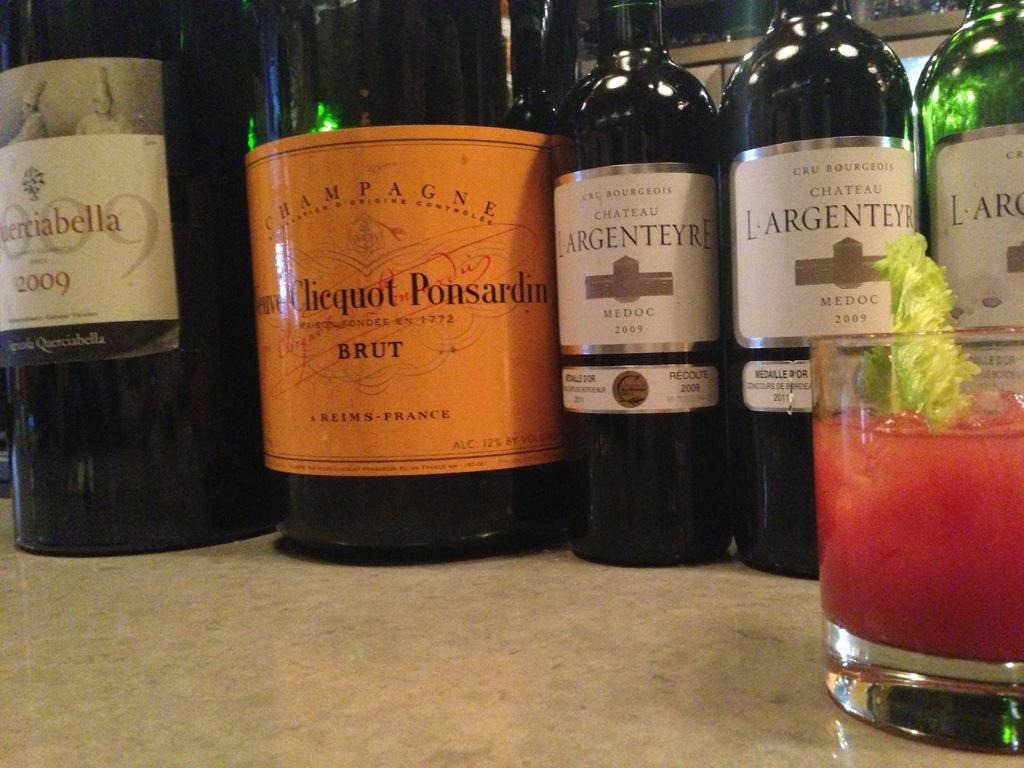<image>
Describe the image concisely. Several bottles of wine next to a magnum bottle of Brut. 